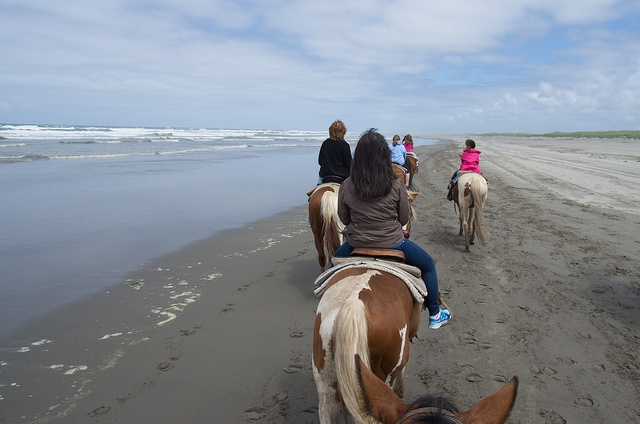Describe the objects in this image and their specific colors. I can see horse in darkgray, brown, gray, and maroon tones, people in darkgray, black, gray, and navy tones, horse in darkgray, black, maroon, and gray tones, horse in darkgray, gray, and black tones, and people in darkgray, black, gray, and maroon tones in this image. 